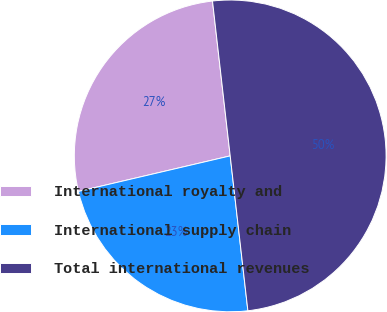Convert chart. <chart><loc_0><loc_0><loc_500><loc_500><pie_chart><fcel>International royalty and<fcel>International supply chain<fcel>Total international revenues<nl><fcel>26.85%<fcel>23.15%<fcel>50.0%<nl></chart> 